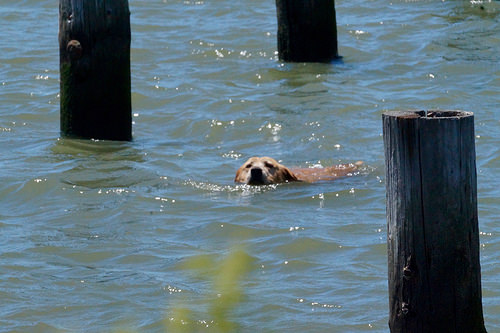<image>
Is the dog behind the grass? Yes. From this viewpoint, the dog is positioned behind the grass, with the grass partially or fully occluding the dog. Is the dog in the water? Yes. The dog is contained within or inside the water, showing a containment relationship. 